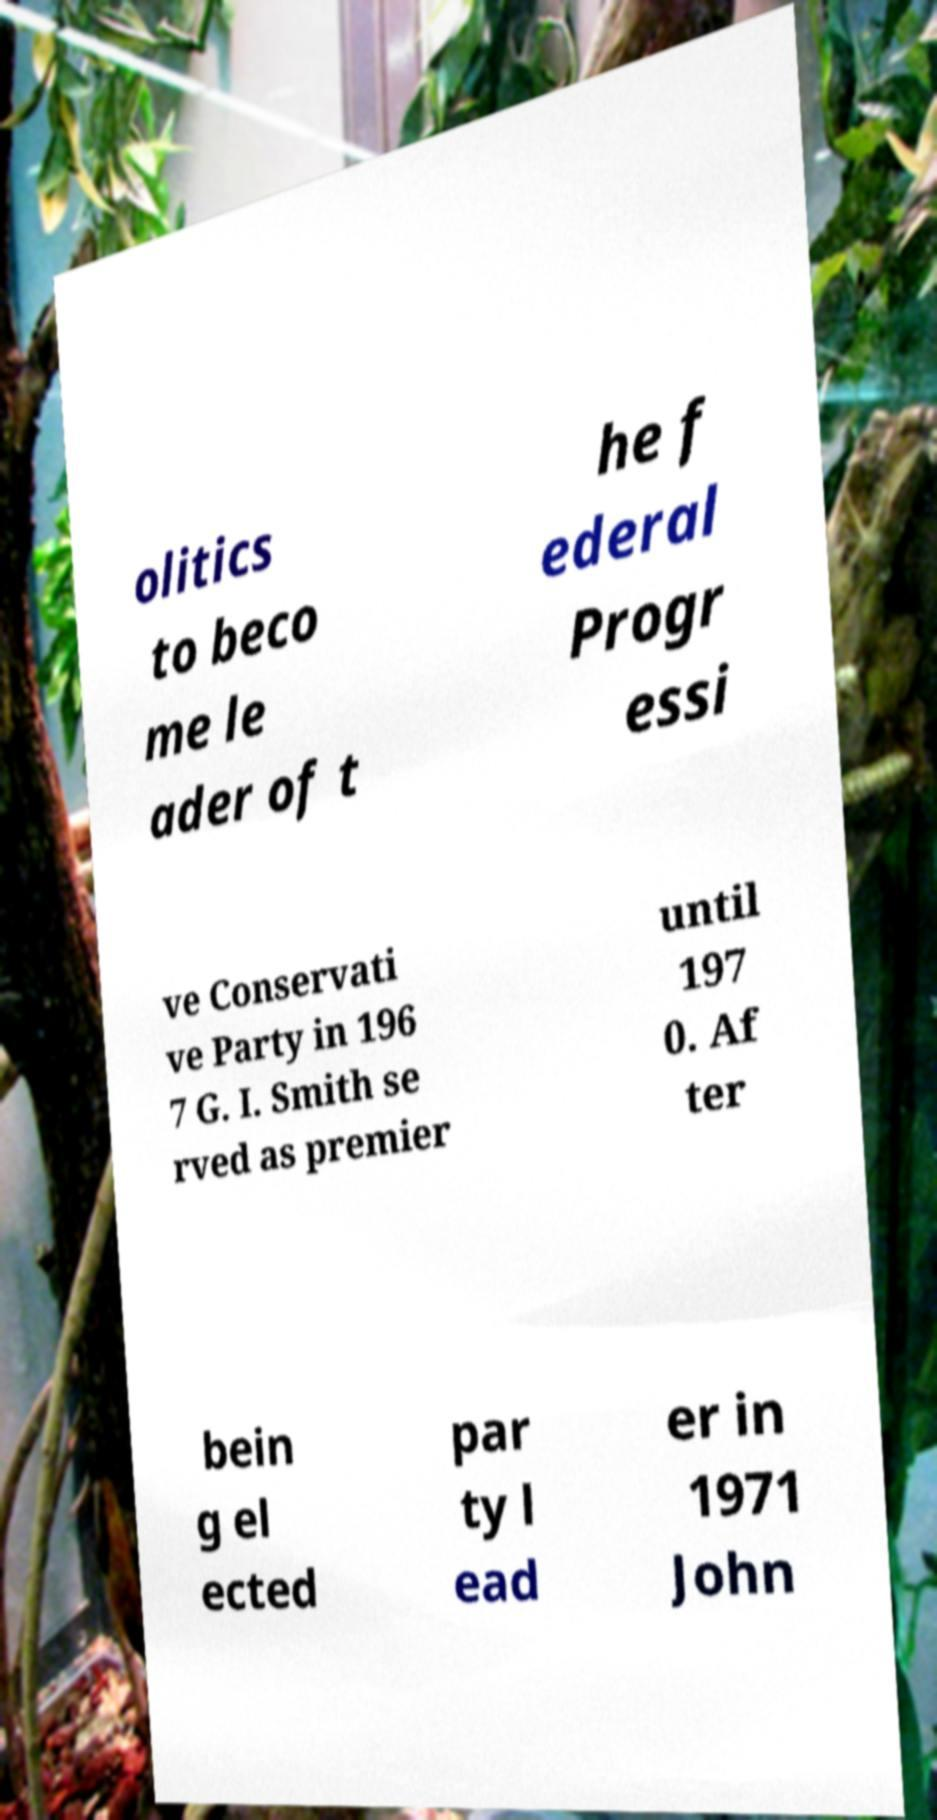Can you accurately transcribe the text from the provided image for me? olitics to beco me le ader of t he f ederal Progr essi ve Conservati ve Party in 196 7 G. I. Smith se rved as premier until 197 0. Af ter bein g el ected par ty l ead er in 1971 John 